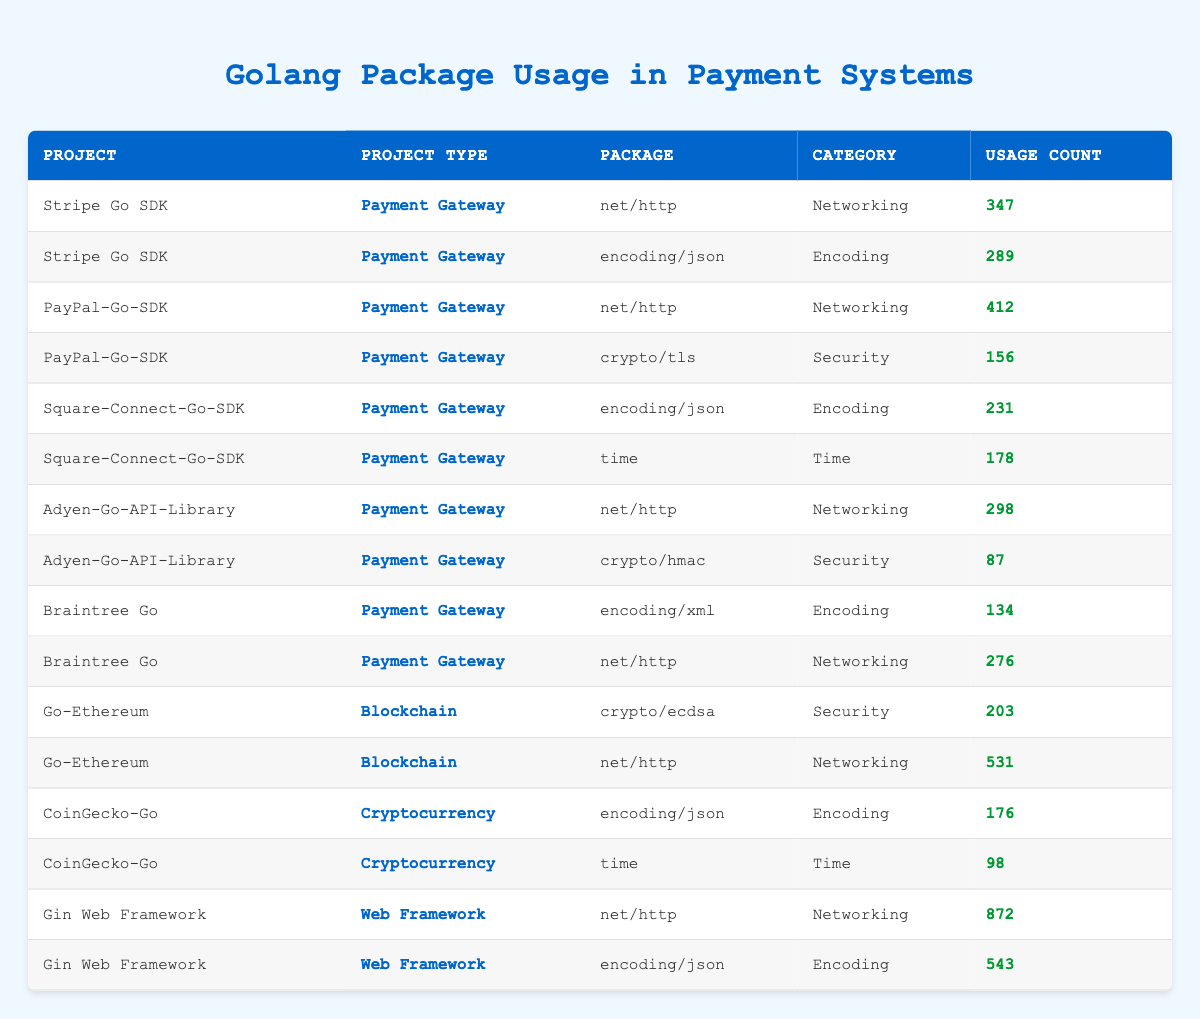What is the total usage count for the package "net/http" across all projects? The usage count for "net/http" can be found in different projects: Stripe Go SDK (347), PayPal-Go-SDK (412), Adyen-Go-API-Library (298), Braintree Go (276), Go-Ethereum (531), and Gin Web Framework (872). Adding these values together gives us 347 + 412 + 298 + 276 + 531 + 872 = 2736.
Answer: 2736 Which project has the highest usage count for the package "encoding/json"? The package "encoding/json" appears in Stripe Go SDK (289), Square-Connect-Go-SDK (231), and Gin Web Framework (543). The highest usage count among these projects is for Gin Web Framework with a usage count of 543.
Answer: Gin Web Framework Is "crypto/tls" used in more projects than "crypto/hmac"? "crypto/tls" is used in one project (PayPal-Go-SDK), while "crypto/hmac" is also used in one project (Adyen-Go-API-Library). Since both packages are used in the same number of projects (one each), the answer is no.
Answer: No What is the average usage count for all packages in the "Encoding" category? The packages in the "Encoding" category are encoding/json (289, 231, 543) and encoding/xml (134). Adding these gives 289 + 231 + 543 + 134 = 1197. There are 4 entries, so the average is 1197 / 4 = 299.25.
Answer: 299.25 Which project type has the highest total usage count? To find the total usage counts for each project type: Payment Gateway sum is (347 + 289 + 412 + 156 + 231 + 178 + 298 + 87 + 134 + 276) = 1800. Blockchain sum is (203 + 531) = 734. Cryptocurrency sum is (176 + 98) = 274. Web Framework sum is (872 + 543) = 1415. The highest is Payment Gateway with 1800.
Answer: Payment Gateway What is the total usage count for the "Security" category? The "Security" category includes crypto/tls (156), crypto/hmac (87), and crypto/ecdsa (203). Adding these counts together gives us 156 + 87 + 203 = 446.
Answer: 446 Is the usage count for the "encoding/json" package in Gin Web Framework higher than that in Braintree Go? In Gin Web Framework, the usage count for encoding/json is 543, and in Braintree Go, it is 134. Since 543 is greater than 134, the statement is true.
Answer: Yes What is the least used package across all projects? The packages with the least usage count are crypto/hmac (87) from Adyen-Go-API-Library and time (98) from CoinGecko-Go. Comparing these, crypto/hmac has the least usage at 87.
Answer: crypto/hmac 